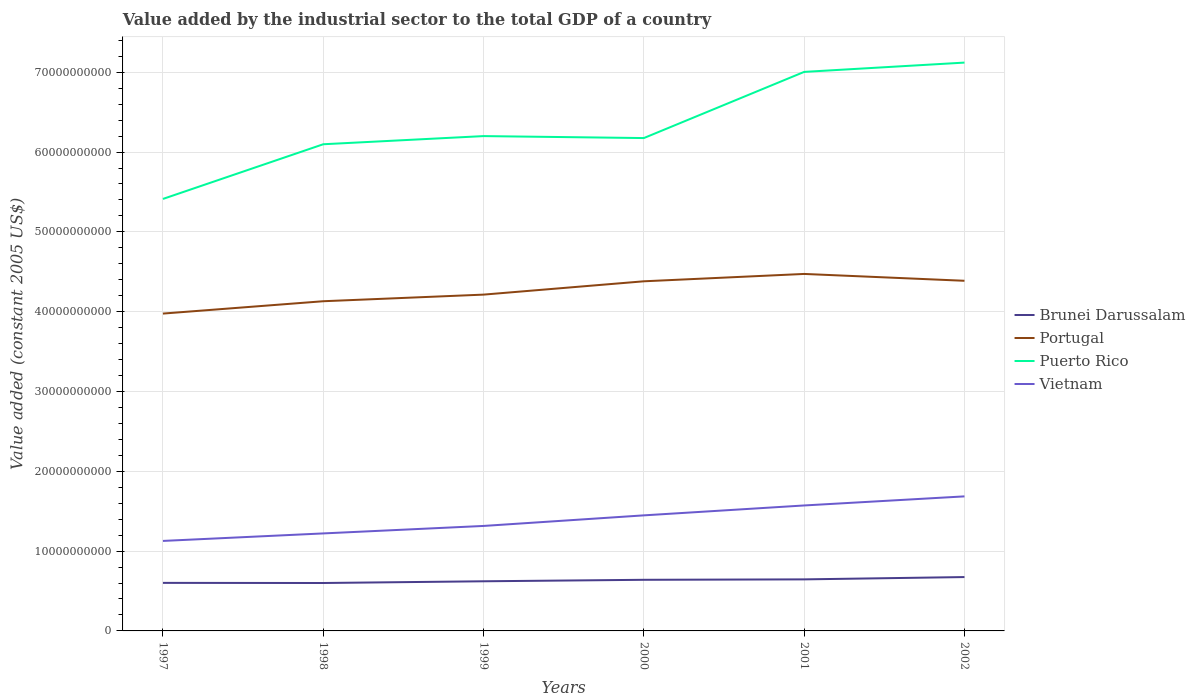Does the line corresponding to Puerto Rico intersect with the line corresponding to Brunei Darussalam?
Offer a very short reply. No. Across all years, what is the maximum value added by the industrial sector in Vietnam?
Make the answer very short. 1.13e+1. In which year was the value added by the industrial sector in Brunei Darussalam maximum?
Your answer should be very brief. 1998. What is the total value added by the industrial sector in Puerto Rico in the graph?
Your response must be concise. -7.76e+08. What is the difference between the highest and the second highest value added by the industrial sector in Vietnam?
Provide a succinct answer. 5.58e+09. What is the difference between the highest and the lowest value added by the industrial sector in Vietnam?
Offer a very short reply. 3. Is the value added by the industrial sector in Portugal strictly greater than the value added by the industrial sector in Brunei Darussalam over the years?
Offer a terse response. No. How many years are there in the graph?
Give a very brief answer. 6. Are the values on the major ticks of Y-axis written in scientific E-notation?
Ensure brevity in your answer.  No. Does the graph contain any zero values?
Your answer should be compact. No. Does the graph contain grids?
Your answer should be very brief. Yes. What is the title of the graph?
Make the answer very short. Value added by the industrial sector to the total GDP of a country. Does "Central Europe" appear as one of the legend labels in the graph?
Your response must be concise. No. What is the label or title of the Y-axis?
Keep it short and to the point. Value added (constant 2005 US$). What is the Value added (constant 2005 US$) in Brunei Darussalam in 1997?
Ensure brevity in your answer.  6.02e+09. What is the Value added (constant 2005 US$) of Portugal in 1997?
Your response must be concise. 3.98e+1. What is the Value added (constant 2005 US$) of Puerto Rico in 1997?
Your answer should be compact. 5.41e+1. What is the Value added (constant 2005 US$) in Vietnam in 1997?
Keep it short and to the point. 1.13e+1. What is the Value added (constant 2005 US$) in Brunei Darussalam in 1998?
Offer a terse response. 6.00e+09. What is the Value added (constant 2005 US$) in Portugal in 1998?
Give a very brief answer. 4.13e+1. What is the Value added (constant 2005 US$) in Puerto Rico in 1998?
Your answer should be compact. 6.10e+1. What is the Value added (constant 2005 US$) of Vietnam in 1998?
Offer a terse response. 1.22e+1. What is the Value added (constant 2005 US$) in Brunei Darussalam in 1999?
Make the answer very short. 6.22e+09. What is the Value added (constant 2005 US$) in Portugal in 1999?
Ensure brevity in your answer.  4.21e+1. What is the Value added (constant 2005 US$) in Puerto Rico in 1999?
Keep it short and to the point. 6.20e+1. What is the Value added (constant 2005 US$) of Vietnam in 1999?
Make the answer very short. 1.32e+1. What is the Value added (constant 2005 US$) in Brunei Darussalam in 2000?
Your answer should be very brief. 6.40e+09. What is the Value added (constant 2005 US$) of Portugal in 2000?
Offer a terse response. 4.38e+1. What is the Value added (constant 2005 US$) of Puerto Rico in 2000?
Offer a terse response. 6.18e+1. What is the Value added (constant 2005 US$) in Vietnam in 2000?
Your response must be concise. 1.45e+1. What is the Value added (constant 2005 US$) of Brunei Darussalam in 2001?
Provide a succinct answer. 6.46e+09. What is the Value added (constant 2005 US$) of Portugal in 2001?
Give a very brief answer. 4.47e+1. What is the Value added (constant 2005 US$) in Puerto Rico in 2001?
Your answer should be compact. 7.00e+1. What is the Value added (constant 2005 US$) in Vietnam in 2001?
Provide a succinct answer. 1.57e+1. What is the Value added (constant 2005 US$) of Brunei Darussalam in 2002?
Offer a terse response. 6.75e+09. What is the Value added (constant 2005 US$) of Portugal in 2002?
Give a very brief answer. 4.39e+1. What is the Value added (constant 2005 US$) of Puerto Rico in 2002?
Your response must be concise. 7.12e+1. What is the Value added (constant 2005 US$) of Vietnam in 2002?
Ensure brevity in your answer.  1.69e+1. Across all years, what is the maximum Value added (constant 2005 US$) of Brunei Darussalam?
Your answer should be compact. 6.75e+09. Across all years, what is the maximum Value added (constant 2005 US$) in Portugal?
Ensure brevity in your answer.  4.47e+1. Across all years, what is the maximum Value added (constant 2005 US$) of Puerto Rico?
Ensure brevity in your answer.  7.12e+1. Across all years, what is the maximum Value added (constant 2005 US$) of Vietnam?
Make the answer very short. 1.69e+1. Across all years, what is the minimum Value added (constant 2005 US$) of Brunei Darussalam?
Give a very brief answer. 6.00e+09. Across all years, what is the minimum Value added (constant 2005 US$) in Portugal?
Offer a very short reply. 3.98e+1. Across all years, what is the minimum Value added (constant 2005 US$) of Puerto Rico?
Offer a very short reply. 5.41e+1. Across all years, what is the minimum Value added (constant 2005 US$) in Vietnam?
Offer a very short reply. 1.13e+1. What is the total Value added (constant 2005 US$) of Brunei Darussalam in the graph?
Give a very brief answer. 3.79e+1. What is the total Value added (constant 2005 US$) in Portugal in the graph?
Offer a terse response. 2.56e+11. What is the total Value added (constant 2005 US$) of Puerto Rico in the graph?
Your answer should be very brief. 3.80e+11. What is the total Value added (constant 2005 US$) of Vietnam in the graph?
Your response must be concise. 8.37e+1. What is the difference between the Value added (constant 2005 US$) of Brunei Darussalam in 1997 and that in 1998?
Ensure brevity in your answer.  1.59e+07. What is the difference between the Value added (constant 2005 US$) of Portugal in 1997 and that in 1998?
Provide a succinct answer. -1.55e+09. What is the difference between the Value added (constant 2005 US$) of Puerto Rico in 1997 and that in 1998?
Your answer should be compact. -6.85e+09. What is the difference between the Value added (constant 2005 US$) in Vietnam in 1997 and that in 1998?
Offer a terse response. -9.40e+08. What is the difference between the Value added (constant 2005 US$) in Brunei Darussalam in 1997 and that in 1999?
Your answer should be very brief. -2.00e+08. What is the difference between the Value added (constant 2005 US$) of Portugal in 1997 and that in 1999?
Make the answer very short. -2.38e+09. What is the difference between the Value added (constant 2005 US$) in Puerto Rico in 1997 and that in 1999?
Your response must be concise. -7.87e+09. What is the difference between the Value added (constant 2005 US$) of Vietnam in 1997 and that in 1999?
Make the answer very short. -1.88e+09. What is the difference between the Value added (constant 2005 US$) of Brunei Darussalam in 1997 and that in 2000?
Your answer should be compact. -3.85e+08. What is the difference between the Value added (constant 2005 US$) of Portugal in 1997 and that in 2000?
Provide a succinct answer. -4.04e+09. What is the difference between the Value added (constant 2005 US$) of Puerto Rico in 1997 and that in 2000?
Your answer should be compact. -7.63e+09. What is the difference between the Value added (constant 2005 US$) of Vietnam in 1997 and that in 2000?
Give a very brief answer. -3.20e+09. What is the difference between the Value added (constant 2005 US$) of Brunei Darussalam in 1997 and that in 2001?
Your answer should be compact. -4.39e+08. What is the difference between the Value added (constant 2005 US$) in Portugal in 1997 and that in 2001?
Give a very brief answer. -4.97e+09. What is the difference between the Value added (constant 2005 US$) in Puerto Rico in 1997 and that in 2001?
Keep it short and to the point. -1.59e+1. What is the difference between the Value added (constant 2005 US$) of Vietnam in 1997 and that in 2001?
Make the answer very short. -4.44e+09. What is the difference between the Value added (constant 2005 US$) in Brunei Darussalam in 1997 and that in 2002?
Ensure brevity in your answer.  -7.29e+08. What is the difference between the Value added (constant 2005 US$) of Portugal in 1997 and that in 2002?
Provide a succinct answer. -4.11e+09. What is the difference between the Value added (constant 2005 US$) in Puerto Rico in 1997 and that in 2002?
Provide a succinct answer. -1.71e+1. What is the difference between the Value added (constant 2005 US$) of Vietnam in 1997 and that in 2002?
Offer a very short reply. -5.58e+09. What is the difference between the Value added (constant 2005 US$) of Brunei Darussalam in 1998 and that in 1999?
Offer a very short reply. -2.16e+08. What is the difference between the Value added (constant 2005 US$) in Portugal in 1998 and that in 1999?
Your answer should be very brief. -8.29e+08. What is the difference between the Value added (constant 2005 US$) of Puerto Rico in 1998 and that in 1999?
Keep it short and to the point. -1.02e+09. What is the difference between the Value added (constant 2005 US$) of Vietnam in 1998 and that in 1999?
Your answer should be very brief. -9.39e+08. What is the difference between the Value added (constant 2005 US$) in Brunei Darussalam in 1998 and that in 2000?
Give a very brief answer. -4.01e+08. What is the difference between the Value added (constant 2005 US$) in Portugal in 1998 and that in 2000?
Keep it short and to the point. -2.50e+09. What is the difference between the Value added (constant 2005 US$) of Puerto Rico in 1998 and that in 2000?
Give a very brief answer. -7.76e+08. What is the difference between the Value added (constant 2005 US$) of Vietnam in 1998 and that in 2000?
Provide a succinct answer. -2.26e+09. What is the difference between the Value added (constant 2005 US$) in Brunei Darussalam in 1998 and that in 2001?
Make the answer very short. -4.55e+08. What is the difference between the Value added (constant 2005 US$) of Portugal in 1998 and that in 2001?
Your answer should be very brief. -3.42e+09. What is the difference between the Value added (constant 2005 US$) of Puerto Rico in 1998 and that in 2001?
Keep it short and to the point. -9.07e+09. What is the difference between the Value added (constant 2005 US$) of Vietnam in 1998 and that in 2001?
Make the answer very short. -3.50e+09. What is the difference between the Value added (constant 2005 US$) of Brunei Darussalam in 1998 and that in 2002?
Offer a terse response. -7.45e+08. What is the difference between the Value added (constant 2005 US$) in Portugal in 1998 and that in 2002?
Provide a succinct answer. -2.56e+09. What is the difference between the Value added (constant 2005 US$) of Puerto Rico in 1998 and that in 2002?
Make the answer very short. -1.02e+1. What is the difference between the Value added (constant 2005 US$) of Vietnam in 1998 and that in 2002?
Provide a succinct answer. -4.64e+09. What is the difference between the Value added (constant 2005 US$) in Brunei Darussalam in 1999 and that in 2000?
Make the answer very short. -1.85e+08. What is the difference between the Value added (constant 2005 US$) of Portugal in 1999 and that in 2000?
Your answer should be very brief. -1.67e+09. What is the difference between the Value added (constant 2005 US$) of Puerto Rico in 1999 and that in 2000?
Provide a succinct answer. 2.48e+08. What is the difference between the Value added (constant 2005 US$) of Vietnam in 1999 and that in 2000?
Keep it short and to the point. -1.32e+09. What is the difference between the Value added (constant 2005 US$) in Brunei Darussalam in 1999 and that in 2001?
Offer a very short reply. -2.39e+08. What is the difference between the Value added (constant 2005 US$) in Portugal in 1999 and that in 2001?
Offer a very short reply. -2.59e+09. What is the difference between the Value added (constant 2005 US$) in Puerto Rico in 1999 and that in 2001?
Your response must be concise. -8.04e+09. What is the difference between the Value added (constant 2005 US$) of Vietnam in 1999 and that in 2001?
Ensure brevity in your answer.  -2.57e+09. What is the difference between the Value added (constant 2005 US$) of Brunei Darussalam in 1999 and that in 2002?
Provide a succinct answer. -5.29e+08. What is the difference between the Value added (constant 2005 US$) of Portugal in 1999 and that in 2002?
Your answer should be very brief. -1.73e+09. What is the difference between the Value added (constant 2005 US$) of Puerto Rico in 1999 and that in 2002?
Provide a short and direct response. -9.21e+09. What is the difference between the Value added (constant 2005 US$) in Vietnam in 1999 and that in 2002?
Give a very brief answer. -3.70e+09. What is the difference between the Value added (constant 2005 US$) in Brunei Darussalam in 2000 and that in 2001?
Your answer should be compact. -5.32e+07. What is the difference between the Value added (constant 2005 US$) in Portugal in 2000 and that in 2001?
Keep it short and to the point. -9.23e+08. What is the difference between the Value added (constant 2005 US$) in Puerto Rico in 2000 and that in 2001?
Your response must be concise. -8.29e+09. What is the difference between the Value added (constant 2005 US$) in Vietnam in 2000 and that in 2001?
Your response must be concise. -1.24e+09. What is the difference between the Value added (constant 2005 US$) in Brunei Darussalam in 2000 and that in 2002?
Make the answer very short. -3.43e+08. What is the difference between the Value added (constant 2005 US$) of Portugal in 2000 and that in 2002?
Your answer should be very brief. -6.47e+07. What is the difference between the Value added (constant 2005 US$) in Puerto Rico in 2000 and that in 2002?
Your answer should be compact. -9.46e+09. What is the difference between the Value added (constant 2005 US$) in Vietnam in 2000 and that in 2002?
Make the answer very short. -2.38e+09. What is the difference between the Value added (constant 2005 US$) of Brunei Darussalam in 2001 and that in 2002?
Offer a terse response. -2.90e+08. What is the difference between the Value added (constant 2005 US$) of Portugal in 2001 and that in 2002?
Ensure brevity in your answer.  8.58e+08. What is the difference between the Value added (constant 2005 US$) in Puerto Rico in 2001 and that in 2002?
Offer a terse response. -1.16e+09. What is the difference between the Value added (constant 2005 US$) in Vietnam in 2001 and that in 2002?
Make the answer very short. -1.14e+09. What is the difference between the Value added (constant 2005 US$) in Brunei Darussalam in 1997 and the Value added (constant 2005 US$) in Portugal in 1998?
Your answer should be very brief. -3.53e+1. What is the difference between the Value added (constant 2005 US$) in Brunei Darussalam in 1997 and the Value added (constant 2005 US$) in Puerto Rico in 1998?
Give a very brief answer. -5.50e+1. What is the difference between the Value added (constant 2005 US$) in Brunei Darussalam in 1997 and the Value added (constant 2005 US$) in Vietnam in 1998?
Ensure brevity in your answer.  -6.20e+09. What is the difference between the Value added (constant 2005 US$) of Portugal in 1997 and the Value added (constant 2005 US$) of Puerto Rico in 1998?
Provide a short and direct response. -2.12e+1. What is the difference between the Value added (constant 2005 US$) of Portugal in 1997 and the Value added (constant 2005 US$) of Vietnam in 1998?
Your answer should be compact. 2.75e+1. What is the difference between the Value added (constant 2005 US$) of Puerto Rico in 1997 and the Value added (constant 2005 US$) of Vietnam in 1998?
Make the answer very short. 4.19e+1. What is the difference between the Value added (constant 2005 US$) of Brunei Darussalam in 1997 and the Value added (constant 2005 US$) of Portugal in 1999?
Ensure brevity in your answer.  -3.61e+1. What is the difference between the Value added (constant 2005 US$) in Brunei Darussalam in 1997 and the Value added (constant 2005 US$) in Puerto Rico in 1999?
Make the answer very short. -5.60e+1. What is the difference between the Value added (constant 2005 US$) in Brunei Darussalam in 1997 and the Value added (constant 2005 US$) in Vietnam in 1999?
Give a very brief answer. -7.13e+09. What is the difference between the Value added (constant 2005 US$) in Portugal in 1997 and the Value added (constant 2005 US$) in Puerto Rico in 1999?
Your response must be concise. -2.22e+1. What is the difference between the Value added (constant 2005 US$) in Portugal in 1997 and the Value added (constant 2005 US$) in Vietnam in 1999?
Your response must be concise. 2.66e+1. What is the difference between the Value added (constant 2005 US$) in Puerto Rico in 1997 and the Value added (constant 2005 US$) in Vietnam in 1999?
Your answer should be very brief. 4.10e+1. What is the difference between the Value added (constant 2005 US$) of Brunei Darussalam in 1997 and the Value added (constant 2005 US$) of Portugal in 2000?
Your response must be concise. -3.78e+1. What is the difference between the Value added (constant 2005 US$) of Brunei Darussalam in 1997 and the Value added (constant 2005 US$) of Puerto Rico in 2000?
Offer a very short reply. -5.57e+1. What is the difference between the Value added (constant 2005 US$) of Brunei Darussalam in 1997 and the Value added (constant 2005 US$) of Vietnam in 2000?
Your answer should be compact. -8.46e+09. What is the difference between the Value added (constant 2005 US$) of Portugal in 1997 and the Value added (constant 2005 US$) of Puerto Rico in 2000?
Keep it short and to the point. -2.20e+1. What is the difference between the Value added (constant 2005 US$) in Portugal in 1997 and the Value added (constant 2005 US$) in Vietnam in 2000?
Give a very brief answer. 2.53e+1. What is the difference between the Value added (constant 2005 US$) of Puerto Rico in 1997 and the Value added (constant 2005 US$) of Vietnam in 2000?
Offer a terse response. 3.96e+1. What is the difference between the Value added (constant 2005 US$) in Brunei Darussalam in 1997 and the Value added (constant 2005 US$) in Portugal in 2001?
Provide a succinct answer. -3.87e+1. What is the difference between the Value added (constant 2005 US$) of Brunei Darussalam in 1997 and the Value added (constant 2005 US$) of Puerto Rico in 2001?
Offer a very short reply. -6.40e+1. What is the difference between the Value added (constant 2005 US$) of Brunei Darussalam in 1997 and the Value added (constant 2005 US$) of Vietnam in 2001?
Keep it short and to the point. -9.70e+09. What is the difference between the Value added (constant 2005 US$) of Portugal in 1997 and the Value added (constant 2005 US$) of Puerto Rico in 2001?
Offer a terse response. -3.03e+1. What is the difference between the Value added (constant 2005 US$) in Portugal in 1997 and the Value added (constant 2005 US$) in Vietnam in 2001?
Provide a succinct answer. 2.40e+1. What is the difference between the Value added (constant 2005 US$) of Puerto Rico in 1997 and the Value added (constant 2005 US$) of Vietnam in 2001?
Keep it short and to the point. 3.84e+1. What is the difference between the Value added (constant 2005 US$) of Brunei Darussalam in 1997 and the Value added (constant 2005 US$) of Portugal in 2002?
Provide a short and direct response. -3.79e+1. What is the difference between the Value added (constant 2005 US$) of Brunei Darussalam in 1997 and the Value added (constant 2005 US$) of Puerto Rico in 2002?
Offer a very short reply. -6.52e+1. What is the difference between the Value added (constant 2005 US$) of Brunei Darussalam in 1997 and the Value added (constant 2005 US$) of Vietnam in 2002?
Give a very brief answer. -1.08e+1. What is the difference between the Value added (constant 2005 US$) in Portugal in 1997 and the Value added (constant 2005 US$) in Puerto Rico in 2002?
Ensure brevity in your answer.  -3.14e+1. What is the difference between the Value added (constant 2005 US$) in Portugal in 1997 and the Value added (constant 2005 US$) in Vietnam in 2002?
Give a very brief answer. 2.29e+1. What is the difference between the Value added (constant 2005 US$) of Puerto Rico in 1997 and the Value added (constant 2005 US$) of Vietnam in 2002?
Provide a succinct answer. 3.73e+1. What is the difference between the Value added (constant 2005 US$) of Brunei Darussalam in 1998 and the Value added (constant 2005 US$) of Portugal in 1999?
Keep it short and to the point. -3.61e+1. What is the difference between the Value added (constant 2005 US$) of Brunei Darussalam in 1998 and the Value added (constant 2005 US$) of Puerto Rico in 1999?
Keep it short and to the point. -5.60e+1. What is the difference between the Value added (constant 2005 US$) of Brunei Darussalam in 1998 and the Value added (constant 2005 US$) of Vietnam in 1999?
Your answer should be very brief. -7.15e+09. What is the difference between the Value added (constant 2005 US$) of Portugal in 1998 and the Value added (constant 2005 US$) of Puerto Rico in 1999?
Give a very brief answer. -2.07e+1. What is the difference between the Value added (constant 2005 US$) in Portugal in 1998 and the Value added (constant 2005 US$) in Vietnam in 1999?
Offer a very short reply. 2.82e+1. What is the difference between the Value added (constant 2005 US$) in Puerto Rico in 1998 and the Value added (constant 2005 US$) in Vietnam in 1999?
Offer a terse response. 4.78e+1. What is the difference between the Value added (constant 2005 US$) in Brunei Darussalam in 1998 and the Value added (constant 2005 US$) in Portugal in 2000?
Your response must be concise. -3.78e+1. What is the difference between the Value added (constant 2005 US$) of Brunei Darussalam in 1998 and the Value added (constant 2005 US$) of Puerto Rico in 2000?
Give a very brief answer. -5.57e+1. What is the difference between the Value added (constant 2005 US$) in Brunei Darussalam in 1998 and the Value added (constant 2005 US$) in Vietnam in 2000?
Your answer should be compact. -8.48e+09. What is the difference between the Value added (constant 2005 US$) in Portugal in 1998 and the Value added (constant 2005 US$) in Puerto Rico in 2000?
Provide a succinct answer. -2.04e+1. What is the difference between the Value added (constant 2005 US$) in Portugal in 1998 and the Value added (constant 2005 US$) in Vietnam in 2000?
Provide a succinct answer. 2.68e+1. What is the difference between the Value added (constant 2005 US$) of Puerto Rico in 1998 and the Value added (constant 2005 US$) of Vietnam in 2000?
Provide a succinct answer. 4.65e+1. What is the difference between the Value added (constant 2005 US$) of Brunei Darussalam in 1998 and the Value added (constant 2005 US$) of Portugal in 2001?
Provide a succinct answer. -3.87e+1. What is the difference between the Value added (constant 2005 US$) in Brunei Darussalam in 1998 and the Value added (constant 2005 US$) in Puerto Rico in 2001?
Your answer should be compact. -6.40e+1. What is the difference between the Value added (constant 2005 US$) in Brunei Darussalam in 1998 and the Value added (constant 2005 US$) in Vietnam in 2001?
Offer a very short reply. -9.72e+09. What is the difference between the Value added (constant 2005 US$) of Portugal in 1998 and the Value added (constant 2005 US$) of Puerto Rico in 2001?
Make the answer very short. -2.87e+1. What is the difference between the Value added (constant 2005 US$) of Portugal in 1998 and the Value added (constant 2005 US$) of Vietnam in 2001?
Your answer should be compact. 2.56e+1. What is the difference between the Value added (constant 2005 US$) in Puerto Rico in 1998 and the Value added (constant 2005 US$) in Vietnam in 2001?
Your response must be concise. 4.53e+1. What is the difference between the Value added (constant 2005 US$) of Brunei Darussalam in 1998 and the Value added (constant 2005 US$) of Portugal in 2002?
Give a very brief answer. -3.79e+1. What is the difference between the Value added (constant 2005 US$) of Brunei Darussalam in 1998 and the Value added (constant 2005 US$) of Puerto Rico in 2002?
Provide a succinct answer. -6.52e+1. What is the difference between the Value added (constant 2005 US$) in Brunei Darussalam in 1998 and the Value added (constant 2005 US$) in Vietnam in 2002?
Offer a terse response. -1.09e+1. What is the difference between the Value added (constant 2005 US$) in Portugal in 1998 and the Value added (constant 2005 US$) in Puerto Rico in 2002?
Your answer should be compact. -2.99e+1. What is the difference between the Value added (constant 2005 US$) in Portugal in 1998 and the Value added (constant 2005 US$) in Vietnam in 2002?
Your answer should be very brief. 2.45e+1. What is the difference between the Value added (constant 2005 US$) of Puerto Rico in 1998 and the Value added (constant 2005 US$) of Vietnam in 2002?
Your response must be concise. 4.41e+1. What is the difference between the Value added (constant 2005 US$) of Brunei Darussalam in 1999 and the Value added (constant 2005 US$) of Portugal in 2000?
Give a very brief answer. -3.76e+1. What is the difference between the Value added (constant 2005 US$) in Brunei Darussalam in 1999 and the Value added (constant 2005 US$) in Puerto Rico in 2000?
Your answer should be compact. -5.55e+1. What is the difference between the Value added (constant 2005 US$) in Brunei Darussalam in 1999 and the Value added (constant 2005 US$) in Vietnam in 2000?
Ensure brevity in your answer.  -8.26e+09. What is the difference between the Value added (constant 2005 US$) in Portugal in 1999 and the Value added (constant 2005 US$) in Puerto Rico in 2000?
Make the answer very short. -1.96e+1. What is the difference between the Value added (constant 2005 US$) of Portugal in 1999 and the Value added (constant 2005 US$) of Vietnam in 2000?
Your response must be concise. 2.77e+1. What is the difference between the Value added (constant 2005 US$) in Puerto Rico in 1999 and the Value added (constant 2005 US$) in Vietnam in 2000?
Keep it short and to the point. 4.75e+1. What is the difference between the Value added (constant 2005 US$) of Brunei Darussalam in 1999 and the Value added (constant 2005 US$) of Portugal in 2001?
Offer a terse response. -3.85e+1. What is the difference between the Value added (constant 2005 US$) in Brunei Darussalam in 1999 and the Value added (constant 2005 US$) in Puerto Rico in 2001?
Keep it short and to the point. -6.38e+1. What is the difference between the Value added (constant 2005 US$) in Brunei Darussalam in 1999 and the Value added (constant 2005 US$) in Vietnam in 2001?
Keep it short and to the point. -9.50e+09. What is the difference between the Value added (constant 2005 US$) in Portugal in 1999 and the Value added (constant 2005 US$) in Puerto Rico in 2001?
Ensure brevity in your answer.  -2.79e+1. What is the difference between the Value added (constant 2005 US$) in Portugal in 1999 and the Value added (constant 2005 US$) in Vietnam in 2001?
Offer a very short reply. 2.64e+1. What is the difference between the Value added (constant 2005 US$) in Puerto Rico in 1999 and the Value added (constant 2005 US$) in Vietnam in 2001?
Give a very brief answer. 4.63e+1. What is the difference between the Value added (constant 2005 US$) in Brunei Darussalam in 1999 and the Value added (constant 2005 US$) in Portugal in 2002?
Offer a very short reply. -3.77e+1. What is the difference between the Value added (constant 2005 US$) of Brunei Darussalam in 1999 and the Value added (constant 2005 US$) of Puerto Rico in 2002?
Keep it short and to the point. -6.50e+1. What is the difference between the Value added (constant 2005 US$) in Brunei Darussalam in 1999 and the Value added (constant 2005 US$) in Vietnam in 2002?
Your answer should be very brief. -1.06e+1. What is the difference between the Value added (constant 2005 US$) in Portugal in 1999 and the Value added (constant 2005 US$) in Puerto Rico in 2002?
Your response must be concise. -2.91e+1. What is the difference between the Value added (constant 2005 US$) of Portugal in 1999 and the Value added (constant 2005 US$) of Vietnam in 2002?
Your response must be concise. 2.53e+1. What is the difference between the Value added (constant 2005 US$) in Puerto Rico in 1999 and the Value added (constant 2005 US$) in Vietnam in 2002?
Provide a short and direct response. 4.51e+1. What is the difference between the Value added (constant 2005 US$) of Brunei Darussalam in 2000 and the Value added (constant 2005 US$) of Portugal in 2001?
Your response must be concise. -3.83e+1. What is the difference between the Value added (constant 2005 US$) of Brunei Darussalam in 2000 and the Value added (constant 2005 US$) of Puerto Rico in 2001?
Provide a short and direct response. -6.36e+1. What is the difference between the Value added (constant 2005 US$) of Brunei Darussalam in 2000 and the Value added (constant 2005 US$) of Vietnam in 2001?
Give a very brief answer. -9.31e+09. What is the difference between the Value added (constant 2005 US$) of Portugal in 2000 and the Value added (constant 2005 US$) of Puerto Rico in 2001?
Ensure brevity in your answer.  -2.62e+1. What is the difference between the Value added (constant 2005 US$) in Portugal in 2000 and the Value added (constant 2005 US$) in Vietnam in 2001?
Your answer should be compact. 2.81e+1. What is the difference between the Value added (constant 2005 US$) of Puerto Rico in 2000 and the Value added (constant 2005 US$) of Vietnam in 2001?
Keep it short and to the point. 4.60e+1. What is the difference between the Value added (constant 2005 US$) in Brunei Darussalam in 2000 and the Value added (constant 2005 US$) in Portugal in 2002?
Your answer should be compact. -3.75e+1. What is the difference between the Value added (constant 2005 US$) of Brunei Darussalam in 2000 and the Value added (constant 2005 US$) of Puerto Rico in 2002?
Your answer should be very brief. -6.48e+1. What is the difference between the Value added (constant 2005 US$) of Brunei Darussalam in 2000 and the Value added (constant 2005 US$) of Vietnam in 2002?
Offer a terse response. -1.05e+1. What is the difference between the Value added (constant 2005 US$) of Portugal in 2000 and the Value added (constant 2005 US$) of Puerto Rico in 2002?
Your answer should be compact. -2.74e+1. What is the difference between the Value added (constant 2005 US$) in Portugal in 2000 and the Value added (constant 2005 US$) in Vietnam in 2002?
Keep it short and to the point. 2.69e+1. What is the difference between the Value added (constant 2005 US$) in Puerto Rico in 2000 and the Value added (constant 2005 US$) in Vietnam in 2002?
Ensure brevity in your answer.  4.49e+1. What is the difference between the Value added (constant 2005 US$) of Brunei Darussalam in 2001 and the Value added (constant 2005 US$) of Portugal in 2002?
Keep it short and to the point. -3.74e+1. What is the difference between the Value added (constant 2005 US$) of Brunei Darussalam in 2001 and the Value added (constant 2005 US$) of Puerto Rico in 2002?
Keep it short and to the point. -6.48e+1. What is the difference between the Value added (constant 2005 US$) of Brunei Darussalam in 2001 and the Value added (constant 2005 US$) of Vietnam in 2002?
Your response must be concise. -1.04e+1. What is the difference between the Value added (constant 2005 US$) in Portugal in 2001 and the Value added (constant 2005 US$) in Puerto Rico in 2002?
Make the answer very short. -2.65e+1. What is the difference between the Value added (constant 2005 US$) of Portugal in 2001 and the Value added (constant 2005 US$) of Vietnam in 2002?
Provide a succinct answer. 2.79e+1. What is the difference between the Value added (constant 2005 US$) in Puerto Rico in 2001 and the Value added (constant 2005 US$) in Vietnam in 2002?
Make the answer very short. 5.32e+1. What is the average Value added (constant 2005 US$) in Brunei Darussalam per year?
Make the answer very short. 6.31e+09. What is the average Value added (constant 2005 US$) in Portugal per year?
Your answer should be very brief. 4.26e+1. What is the average Value added (constant 2005 US$) of Puerto Rico per year?
Provide a short and direct response. 6.34e+1. What is the average Value added (constant 2005 US$) in Vietnam per year?
Offer a very short reply. 1.40e+1. In the year 1997, what is the difference between the Value added (constant 2005 US$) in Brunei Darussalam and Value added (constant 2005 US$) in Portugal?
Provide a succinct answer. -3.37e+1. In the year 1997, what is the difference between the Value added (constant 2005 US$) in Brunei Darussalam and Value added (constant 2005 US$) in Puerto Rico?
Your response must be concise. -4.81e+1. In the year 1997, what is the difference between the Value added (constant 2005 US$) in Brunei Darussalam and Value added (constant 2005 US$) in Vietnam?
Give a very brief answer. -5.26e+09. In the year 1997, what is the difference between the Value added (constant 2005 US$) in Portugal and Value added (constant 2005 US$) in Puerto Rico?
Your response must be concise. -1.44e+1. In the year 1997, what is the difference between the Value added (constant 2005 US$) of Portugal and Value added (constant 2005 US$) of Vietnam?
Ensure brevity in your answer.  2.85e+1. In the year 1997, what is the difference between the Value added (constant 2005 US$) in Puerto Rico and Value added (constant 2005 US$) in Vietnam?
Ensure brevity in your answer.  4.28e+1. In the year 1998, what is the difference between the Value added (constant 2005 US$) of Brunei Darussalam and Value added (constant 2005 US$) of Portugal?
Your answer should be very brief. -3.53e+1. In the year 1998, what is the difference between the Value added (constant 2005 US$) in Brunei Darussalam and Value added (constant 2005 US$) in Puerto Rico?
Your response must be concise. -5.50e+1. In the year 1998, what is the difference between the Value added (constant 2005 US$) of Brunei Darussalam and Value added (constant 2005 US$) of Vietnam?
Your answer should be compact. -6.21e+09. In the year 1998, what is the difference between the Value added (constant 2005 US$) of Portugal and Value added (constant 2005 US$) of Puerto Rico?
Ensure brevity in your answer.  -1.97e+1. In the year 1998, what is the difference between the Value added (constant 2005 US$) in Portugal and Value added (constant 2005 US$) in Vietnam?
Give a very brief answer. 2.91e+1. In the year 1998, what is the difference between the Value added (constant 2005 US$) of Puerto Rico and Value added (constant 2005 US$) of Vietnam?
Keep it short and to the point. 4.88e+1. In the year 1999, what is the difference between the Value added (constant 2005 US$) of Brunei Darussalam and Value added (constant 2005 US$) of Portugal?
Your response must be concise. -3.59e+1. In the year 1999, what is the difference between the Value added (constant 2005 US$) of Brunei Darussalam and Value added (constant 2005 US$) of Puerto Rico?
Your answer should be compact. -5.58e+1. In the year 1999, what is the difference between the Value added (constant 2005 US$) of Brunei Darussalam and Value added (constant 2005 US$) of Vietnam?
Make the answer very short. -6.93e+09. In the year 1999, what is the difference between the Value added (constant 2005 US$) of Portugal and Value added (constant 2005 US$) of Puerto Rico?
Your answer should be compact. -1.99e+1. In the year 1999, what is the difference between the Value added (constant 2005 US$) in Portugal and Value added (constant 2005 US$) in Vietnam?
Provide a succinct answer. 2.90e+1. In the year 1999, what is the difference between the Value added (constant 2005 US$) of Puerto Rico and Value added (constant 2005 US$) of Vietnam?
Keep it short and to the point. 4.88e+1. In the year 2000, what is the difference between the Value added (constant 2005 US$) in Brunei Darussalam and Value added (constant 2005 US$) in Portugal?
Give a very brief answer. -3.74e+1. In the year 2000, what is the difference between the Value added (constant 2005 US$) in Brunei Darussalam and Value added (constant 2005 US$) in Puerto Rico?
Provide a short and direct response. -5.53e+1. In the year 2000, what is the difference between the Value added (constant 2005 US$) of Brunei Darussalam and Value added (constant 2005 US$) of Vietnam?
Make the answer very short. -8.07e+09. In the year 2000, what is the difference between the Value added (constant 2005 US$) in Portugal and Value added (constant 2005 US$) in Puerto Rico?
Make the answer very short. -1.79e+1. In the year 2000, what is the difference between the Value added (constant 2005 US$) in Portugal and Value added (constant 2005 US$) in Vietnam?
Provide a short and direct response. 2.93e+1. In the year 2000, what is the difference between the Value added (constant 2005 US$) of Puerto Rico and Value added (constant 2005 US$) of Vietnam?
Provide a short and direct response. 4.73e+1. In the year 2001, what is the difference between the Value added (constant 2005 US$) in Brunei Darussalam and Value added (constant 2005 US$) in Portugal?
Give a very brief answer. -3.83e+1. In the year 2001, what is the difference between the Value added (constant 2005 US$) in Brunei Darussalam and Value added (constant 2005 US$) in Puerto Rico?
Provide a short and direct response. -6.36e+1. In the year 2001, what is the difference between the Value added (constant 2005 US$) of Brunei Darussalam and Value added (constant 2005 US$) of Vietnam?
Your answer should be compact. -9.26e+09. In the year 2001, what is the difference between the Value added (constant 2005 US$) in Portugal and Value added (constant 2005 US$) in Puerto Rico?
Provide a short and direct response. -2.53e+1. In the year 2001, what is the difference between the Value added (constant 2005 US$) of Portugal and Value added (constant 2005 US$) of Vietnam?
Keep it short and to the point. 2.90e+1. In the year 2001, what is the difference between the Value added (constant 2005 US$) in Puerto Rico and Value added (constant 2005 US$) in Vietnam?
Your answer should be compact. 5.43e+1. In the year 2002, what is the difference between the Value added (constant 2005 US$) of Brunei Darussalam and Value added (constant 2005 US$) of Portugal?
Ensure brevity in your answer.  -3.71e+1. In the year 2002, what is the difference between the Value added (constant 2005 US$) of Brunei Darussalam and Value added (constant 2005 US$) of Puerto Rico?
Offer a very short reply. -6.45e+1. In the year 2002, what is the difference between the Value added (constant 2005 US$) of Brunei Darussalam and Value added (constant 2005 US$) of Vietnam?
Your response must be concise. -1.01e+1. In the year 2002, what is the difference between the Value added (constant 2005 US$) in Portugal and Value added (constant 2005 US$) in Puerto Rico?
Keep it short and to the point. -2.73e+1. In the year 2002, what is the difference between the Value added (constant 2005 US$) of Portugal and Value added (constant 2005 US$) of Vietnam?
Offer a very short reply. 2.70e+1. In the year 2002, what is the difference between the Value added (constant 2005 US$) in Puerto Rico and Value added (constant 2005 US$) in Vietnam?
Your answer should be compact. 5.44e+1. What is the ratio of the Value added (constant 2005 US$) in Portugal in 1997 to that in 1998?
Your response must be concise. 0.96. What is the ratio of the Value added (constant 2005 US$) of Puerto Rico in 1997 to that in 1998?
Offer a very short reply. 0.89. What is the ratio of the Value added (constant 2005 US$) in Brunei Darussalam in 1997 to that in 1999?
Offer a terse response. 0.97. What is the ratio of the Value added (constant 2005 US$) of Portugal in 1997 to that in 1999?
Keep it short and to the point. 0.94. What is the ratio of the Value added (constant 2005 US$) of Puerto Rico in 1997 to that in 1999?
Provide a succinct answer. 0.87. What is the ratio of the Value added (constant 2005 US$) in Vietnam in 1997 to that in 1999?
Make the answer very short. 0.86. What is the ratio of the Value added (constant 2005 US$) of Brunei Darussalam in 1997 to that in 2000?
Your answer should be compact. 0.94. What is the ratio of the Value added (constant 2005 US$) of Portugal in 1997 to that in 2000?
Make the answer very short. 0.91. What is the ratio of the Value added (constant 2005 US$) of Puerto Rico in 1997 to that in 2000?
Keep it short and to the point. 0.88. What is the ratio of the Value added (constant 2005 US$) of Vietnam in 1997 to that in 2000?
Ensure brevity in your answer.  0.78. What is the ratio of the Value added (constant 2005 US$) in Brunei Darussalam in 1997 to that in 2001?
Your answer should be compact. 0.93. What is the ratio of the Value added (constant 2005 US$) of Portugal in 1997 to that in 2001?
Offer a terse response. 0.89. What is the ratio of the Value added (constant 2005 US$) of Puerto Rico in 1997 to that in 2001?
Your response must be concise. 0.77. What is the ratio of the Value added (constant 2005 US$) of Vietnam in 1997 to that in 2001?
Your response must be concise. 0.72. What is the ratio of the Value added (constant 2005 US$) of Brunei Darussalam in 1997 to that in 2002?
Give a very brief answer. 0.89. What is the ratio of the Value added (constant 2005 US$) in Portugal in 1997 to that in 2002?
Offer a terse response. 0.91. What is the ratio of the Value added (constant 2005 US$) in Puerto Rico in 1997 to that in 2002?
Offer a terse response. 0.76. What is the ratio of the Value added (constant 2005 US$) of Vietnam in 1997 to that in 2002?
Offer a terse response. 0.67. What is the ratio of the Value added (constant 2005 US$) of Brunei Darussalam in 1998 to that in 1999?
Make the answer very short. 0.97. What is the ratio of the Value added (constant 2005 US$) of Portugal in 1998 to that in 1999?
Offer a terse response. 0.98. What is the ratio of the Value added (constant 2005 US$) in Puerto Rico in 1998 to that in 1999?
Offer a terse response. 0.98. What is the ratio of the Value added (constant 2005 US$) in Vietnam in 1998 to that in 1999?
Offer a terse response. 0.93. What is the ratio of the Value added (constant 2005 US$) of Brunei Darussalam in 1998 to that in 2000?
Offer a very short reply. 0.94. What is the ratio of the Value added (constant 2005 US$) of Portugal in 1998 to that in 2000?
Offer a very short reply. 0.94. What is the ratio of the Value added (constant 2005 US$) of Puerto Rico in 1998 to that in 2000?
Provide a short and direct response. 0.99. What is the ratio of the Value added (constant 2005 US$) of Vietnam in 1998 to that in 2000?
Offer a very short reply. 0.84. What is the ratio of the Value added (constant 2005 US$) in Brunei Darussalam in 1998 to that in 2001?
Your answer should be very brief. 0.93. What is the ratio of the Value added (constant 2005 US$) of Portugal in 1998 to that in 2001?
Offer a very short reply. 0.92. What is the ratio of the Value added (constant 2005 US$) of Puerto Rico in 1998 to that in 2001?
Ensure brevity in your answer.  0.87. What is the ratio of the Value added (constant 2005 US$) in Vietnam in 1998 to that in 2001?
Your response must be concise. 0.78. What is the ratio of the Value added (constant 2005 US$) in Brunei Darussalam in 1998 to that in 2002?
Keep it short and to the point. 0.89. What is the ratio of the Value added (constant 2005 US$) in Portugal in 1998 to that in 2002?
Your response must be concise. 0.94. What is the ratio of the Value added (constant 2005 US$) of Puerto Rico in 1998 to that in 2002?
Offer a very short reply. 0.86. What is the ratio of the Value added (constant 2005 US$) of Vietnam in 1998 to that in 2002?
Your answer should be very brief. 0.72. What is the ratio of the Value added (constant 2005 US$) in Brunei Darussalam in 1999 to that in 2000?
Offer a terse response. 0.97. What is the ratio of the Value added (constant 2005 US$) in Portugal in 1999 to that in 2000?
Make the answer very short. 0.96. What is the ratio of the Value added (constant 2005 US$) of Vietnam in 1999 to that in 2000?
Your answer should be compact. 0.91. What is the ratio of the Value added (constant 2005 US$) of Brunei Darussalam in 1999 to that in 2001?
Your answer should be very brief. 0.96. What is the ratio of the Value added (constant 2005 US$) in Portugal in 1999 to that in 2001?
Provide a succinct answer. 0.94. What is the ratio of the Value added (constant 2005 US$) of Puerto Rico in 1999 to that in 2001?
Make the answer very short. 0.89. What is the ratio of the Value added (constant 2005 US$) of Vietnam in 1999 to that in 2001?
Ensure brevity in your answer.  0.84. What is the ratio of the Value added (constant 2005 US$) in Brunei Darussalam in 1999 to that in 2002?
Your answer should be compact. 0.92. What is the ratio of the Value added (constant 2005 US$) of Portugal in 1999 to that in 2002?
Provide a short and direct response. 0.96. What is the ratio of the Value added (constant 2005 US$) in Puerto Rico in 1999 to that in 2002?
Your response must be concise. 0.87. What is the ratio of the Value added (constant 2005 US$) of Vietnam in 1999 to that in 2002?
Your answer should be very brief. 0.78. What is the ratio of the Value added (constant 2005 US$) in Portugal in 2000 to that in 2001?
Offer a terse response. 0.98. What is the ratio of the Value added (constant 2005 US$) in Puerto Rico in 2000 to that in 2001?
Offer a very short reply. 0.88. What is the ratio of the Value added (constant 2005 US$) in Vietnam in 2000 to that in 2001?
Your response must be concise. 0.92. What is the ratio of the Value added (constant 2005 US$) in Brunei Darussalam in 2000 to that in 2002?
Your answer should be compact. 0.95. What is the ratio of the Value added (constant 2005 US$) of Portugal in 2000 to that in 2002?
Your answer should be very brief. 1. What is the ratio of the Value added (constant 2005 US$) of Puerto Rico in 2000 to that in 2002?
Provide a succinct answer. 0.87. What is the ratio of the Value added (constant 2005 US$) of Vietnam in 2000 to that in 2002?
Offer a terse response. 0.86. What is the ratio of the Value added (constant 2005 US$) in Brunei Darussalam in 2001 to that in 2002?
Make the answer very short. 0.96. What is the ratio of the Value added (constant 2005 US$) of Portugal in 2001 to that in 2002?
Ensure brevity in your answer.  1.02. What is the ratio of the Value added (constant 2005 US$) in Puerto Rico in 2001 to that in 2002?
Your answer should be compact. 0.98. What is the ratio of the Value added (constant 2005 US$) in Vietnam in 2001 to that in 2002?
Your answer should be very brief. 0.93. What is the difference between the highest and the second highest Value added (constant 2005 US$) in Brunei Darussalam?
Ensure brevity in your answer.  2.90e+08. What is the difference between the highest and the second highest Value added (constant 2005 US$) of Portugal?
Your answer should be compact. 8.58e+08. What is the difference between the highest and the second highest Value added (constant 2005 US$) in Puerto Rico?
Make the answer very short. 1.16e+09. What is the difference between the highest and the second highest Value added (constant 2005 US$) of Vietnam?
Give a very brief answer. 1.14e+09. What is the difference between the highest and the lowest Value added (constant 2005 US$) in Brunei Darussalam?
Ensure brevity in your answer.  7.45e+08. What is the difference between the highest and the lowest Value added (constant 2005 US$) of Portugal?
Your answer should be very brief. 4.97e+09. What is the difference between the highest and the lowest Value added (constant 2005 US$) of Puerto Rico?
Provide a short and direct response. 1.71e+1. What is the difference between the highest and the lowest Value added (constant 2005 US$) of Vietnam?
Keep it short and to the point. 5.58e+09. 